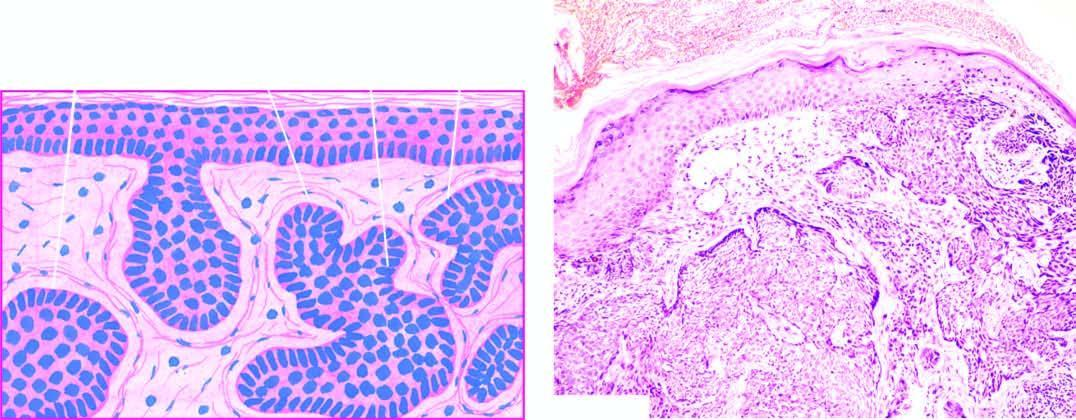re cells separated from dermal collagen by a space called shrinkage artefact?
Answer the question using a single word or phrase. No 